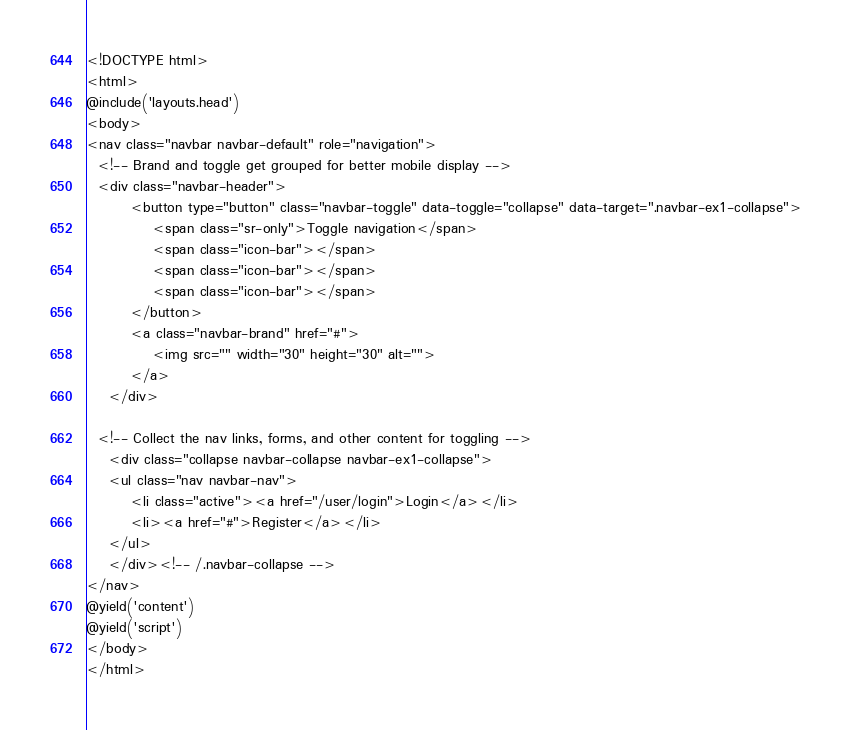<code> <loc_0><loc_0><loc_500><loc_500><_PHP_><!DOCTYPE html>
<html>
@include('layouts.head')
<body>
<nav class="navbar navbar-default" role="navigation">
  <!-- Brand and toggle get grouped for better mobile display -->
  <div class="navbar-header">
    	<button type="button" class="navbar-toggle" data-toggle="collapse" data-target=".navbar-ex1-collapse">
      		<span class="sr-only">Toggle navigation</span>
      		<span class="icon-bar"></span>
      		<span class="icon-bar"></span>
      		<span class="icon-bar"></span>
    	</button>
    	<a class="navbar-brand" href="#">
    		<img src="" width="30" height="30" alt="">
  		</a>
  	</div>

  <!-- Collect the nav links, forms, and other content for toggling -->
  	<div class="collapse navbar-collapse navbar-ex1-collapse">
    <ul class="nav navbar-nav">
      	<li class="active"><a href="/user/login">Login</a></li>
    	<li><a href="#">Register</a></li>
    </ul>
  	</div><!-- /.navbar-collapse -->
</nav>
@yield('content')
@yield('script')
</body>
</html></code> 